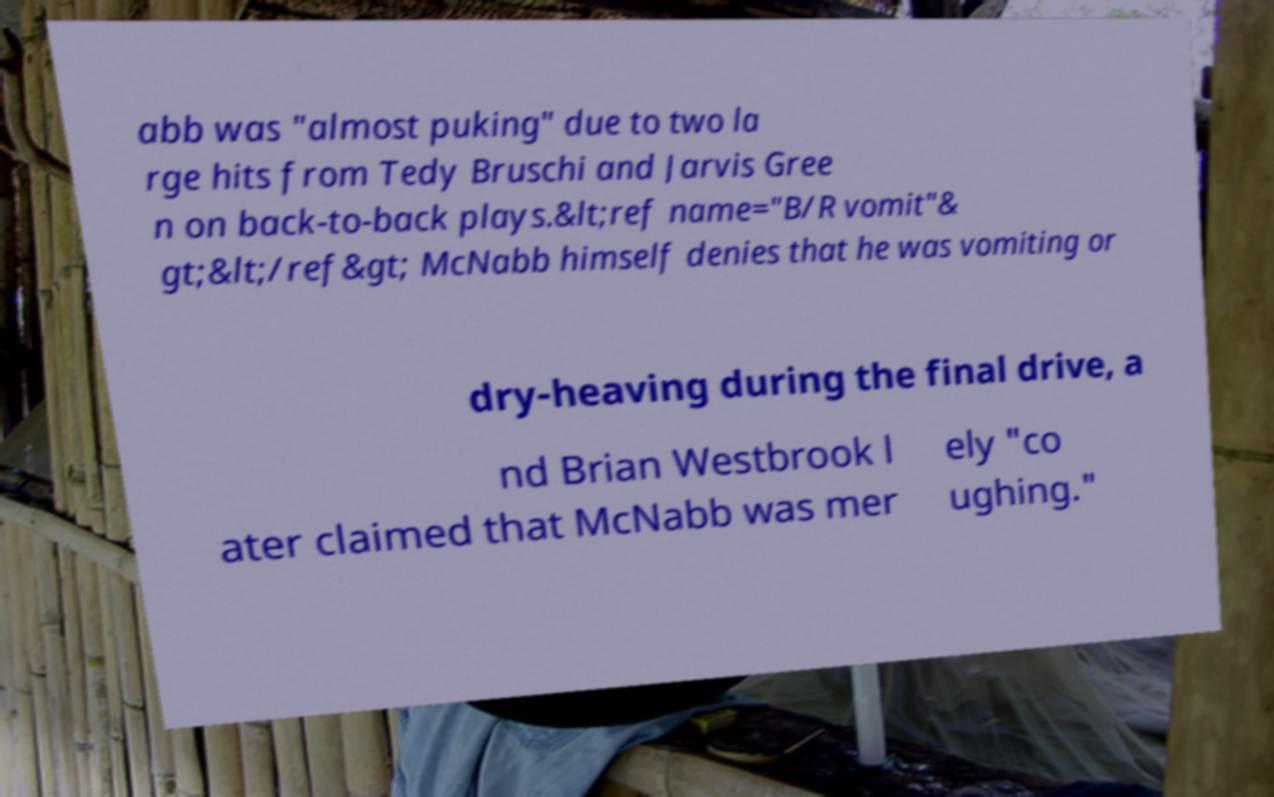What messages or text are displayed in this image? I need them in a readable, typed format. abb was "almost puking" due to two la rge hits from Tedy Bruschi and Jarvis Gree n on back-to-back plays.&lt;ref name="B/R vomit"& gt;&lt;/ref&gt; McNabb himself denies that he was vomiting or dry-heaving during the final drive, a nd Brian Westbrook l ater claimed that McNabb was mer ely "co ughing." 